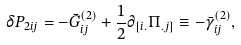Convert formula to latex. <formula><loc_0><loc_0><loc_500><loc_500>\delta P _ { 2 i j } = - \bar { G } _ { i j } ^ { ( 2 ) } + \frac { 1 } { 2 } \partial _ { [ i . } \Pi _ { . j ] } \equiv - \bar { \gamma } _ { i j } ^ { ( 2 ) } ,</formula> 